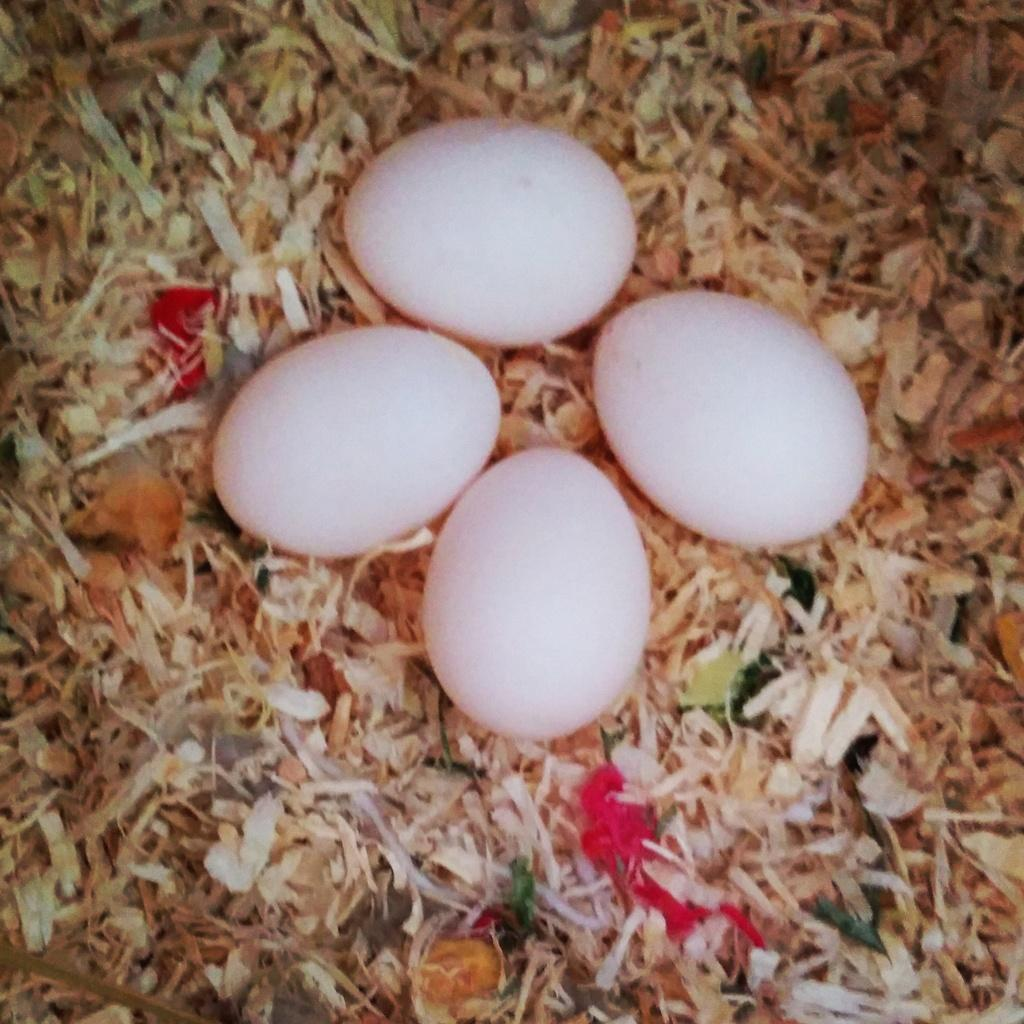How many eggs are present in the image? There are four eggs in the image. What type of vegetation can be seen at the bottom of the image? There is grass visible at the bottom of the image. What type of mint plant can be seen growing in the image? There is no mint plant present in the image. Can you see any pigs or bears in the image? There are no pigs or bears present in the image. 